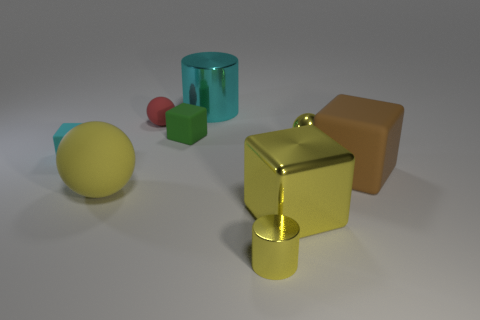How many other objects are the same material as the green thing?
Ensure brevity in your answer.  4. Is the shape of the object on the left side of the big yellow rubber thing the same as the large yellow thing that is left of the large metallic cylinder?
Ensure brevity in your answer.  No. What is the color of the small metal object that is right of the big yellow thing that is to the right of the small sphere left of the small green matte block?
Give a very brief answer. Yellow. How many other things are the same color as the tiny matte ball?
Provide a short and direct response. 0. Is the number of big yellow matte cylinders less than the number of small yellow spheres?
Keep it short and to the point. Yes. What color is the shiny object that is behind the big metallic block and on the left side of the tiny metal sphere?
Offer a terse response. Cyan. What material is the small cyan thing that is the same shape as the green rubber object?
Provide a short and direct response. Rubber. Is the number of large cyan things greater than the number of blue metallic blocks?
Give a very brief answer. Yes. There is a thing that is both on the left side of the yellow cylinder and to the right of the green block; what size is it?
Provide a succinct answer. Large. There is a large yellow shiny object; what shape is it?
Provide a short and direct response. Cube. 